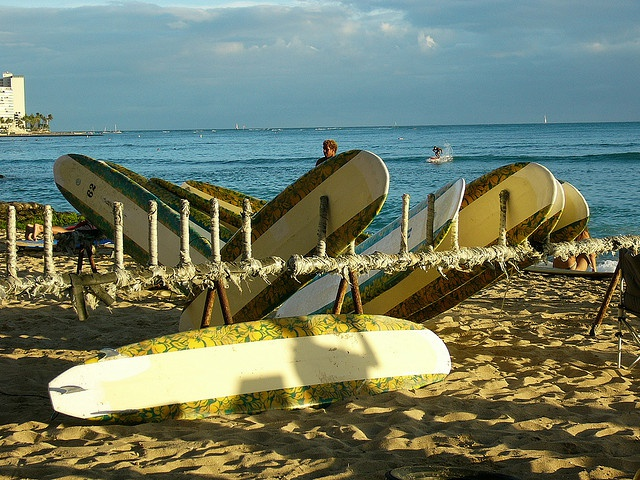Describe the objects in this image and their specific colors. I can see surfboard in lightblue, lightyellow, tan, khaki, and olive tones, surfboard in lightblue, olive, black, maroon, and gray tones, surfboard in lightblue, black, darkgreen, gray, and khaki tones, boat in lightblue, black, darkgreen, gray, and khaki tones, and surfboard in lightblue, olive, gray, and black tones in this image. 